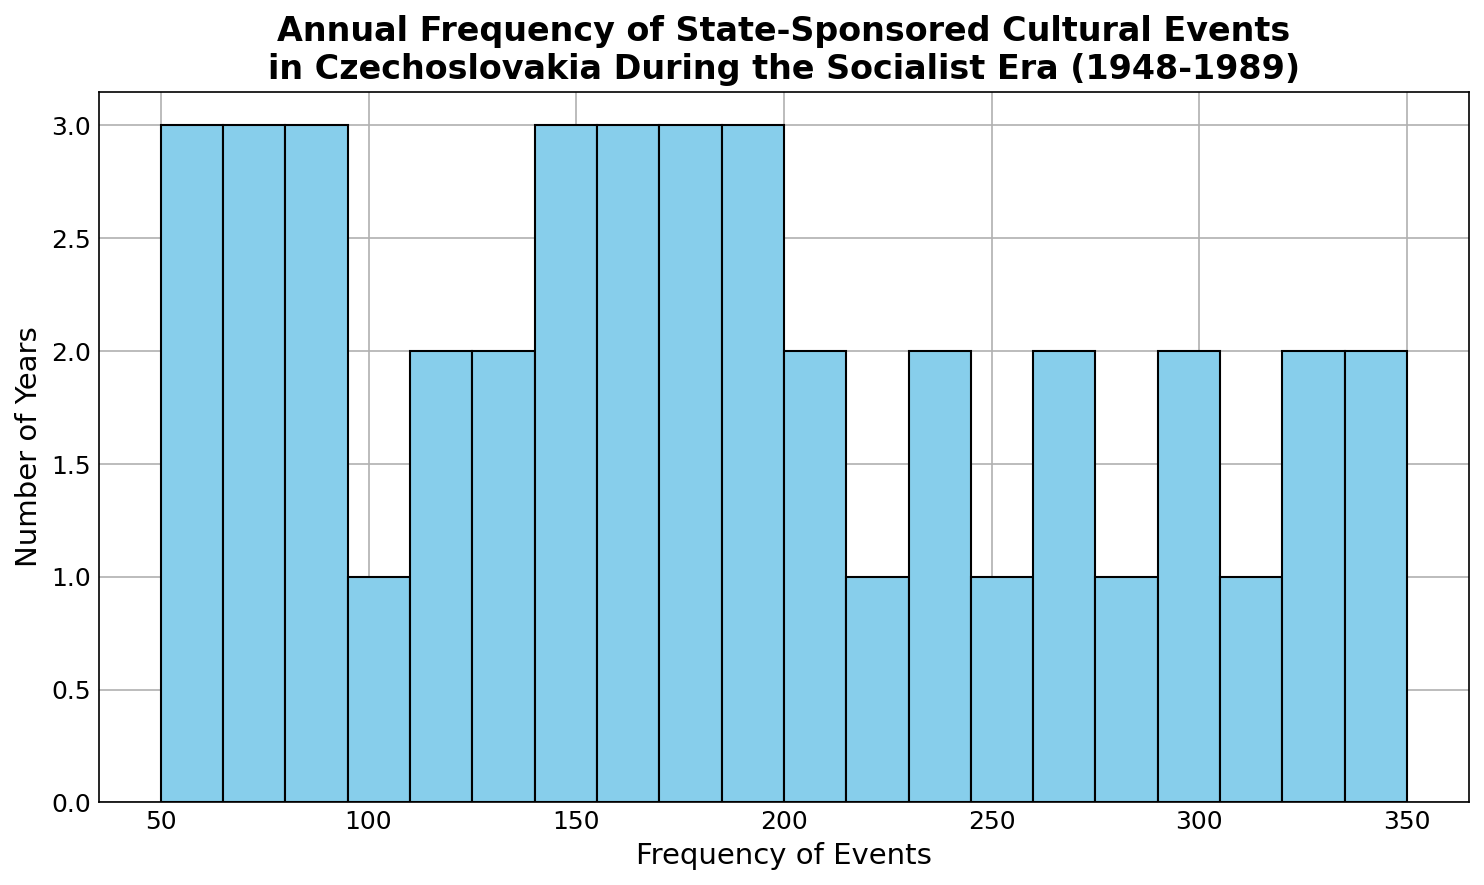How many years had a frequency of cultural events between 200 and 250? To determine the number of years within the range of 200 to 250, count the bins in the histogram that fall within this range. Each bin represents a number of years.
Answer: 5 What is the most frequent range of annual cultural events? Examine the histogram to find the bin with the highest bar. The height of the bar indicates the number of years that a specific range of frequencies occurred.
Answer: 300-350 Which year had the highest annual frequency of state-sponsored cultural events? Look at the histogram and find the rightmost bar, which represents the year with the highest frequency. This corresponds to the year 1989 in the data.
Answer: 1989 How many years had less than 100 annual cultural events? Identify the bins in the histogram that fall in the range from 0 to just below 100. Count these bars to find the total number of years.
Answer: 9 By how much did the frequency of cultural events increase between the first and the last year? The frequency in 1948 was 50, and in 1989 it was 350. Subtract the initial value from the final value to find the increase: 350 - 50.
Answer: 300 What is the average number of annual cultural events in the 1960s? Sum the frequencies from 1960 to 1969 and then divide by the number of years (10). The frequencies are 130, 135, 140, 145, 150, 155, 160, 165, 170, 175. Calculate their total and then the average.
Answer: 152 Compare the number of years with annual cultural events between 180 and 220 with those between 280 and 320. Which range had more years? Count the bars for the range 180-220 and 280-320 and compare their heights in the histogram.
Answer: 280-320 What percentage of years had an annual frequency of cultural events at or above 300? Identify the number of years in the bins at or above 300. There are 3 such years: 300, 310, 320, 330, 340, and 350. Divide this by the total number of years (42) and multiply by 100 to find the percentage.
Answer: ≈14.3% Was there any period where the frequency of cultural events doubled? If yes, between which years? Find a period where the frequency approximately doubled. For example, there was a doubling from 1948 (50 events) to approximately 1958-60 (110-130 events). This can also be double-checked by looking at a span of years.
Answer: Yes, 1948 to 1958 